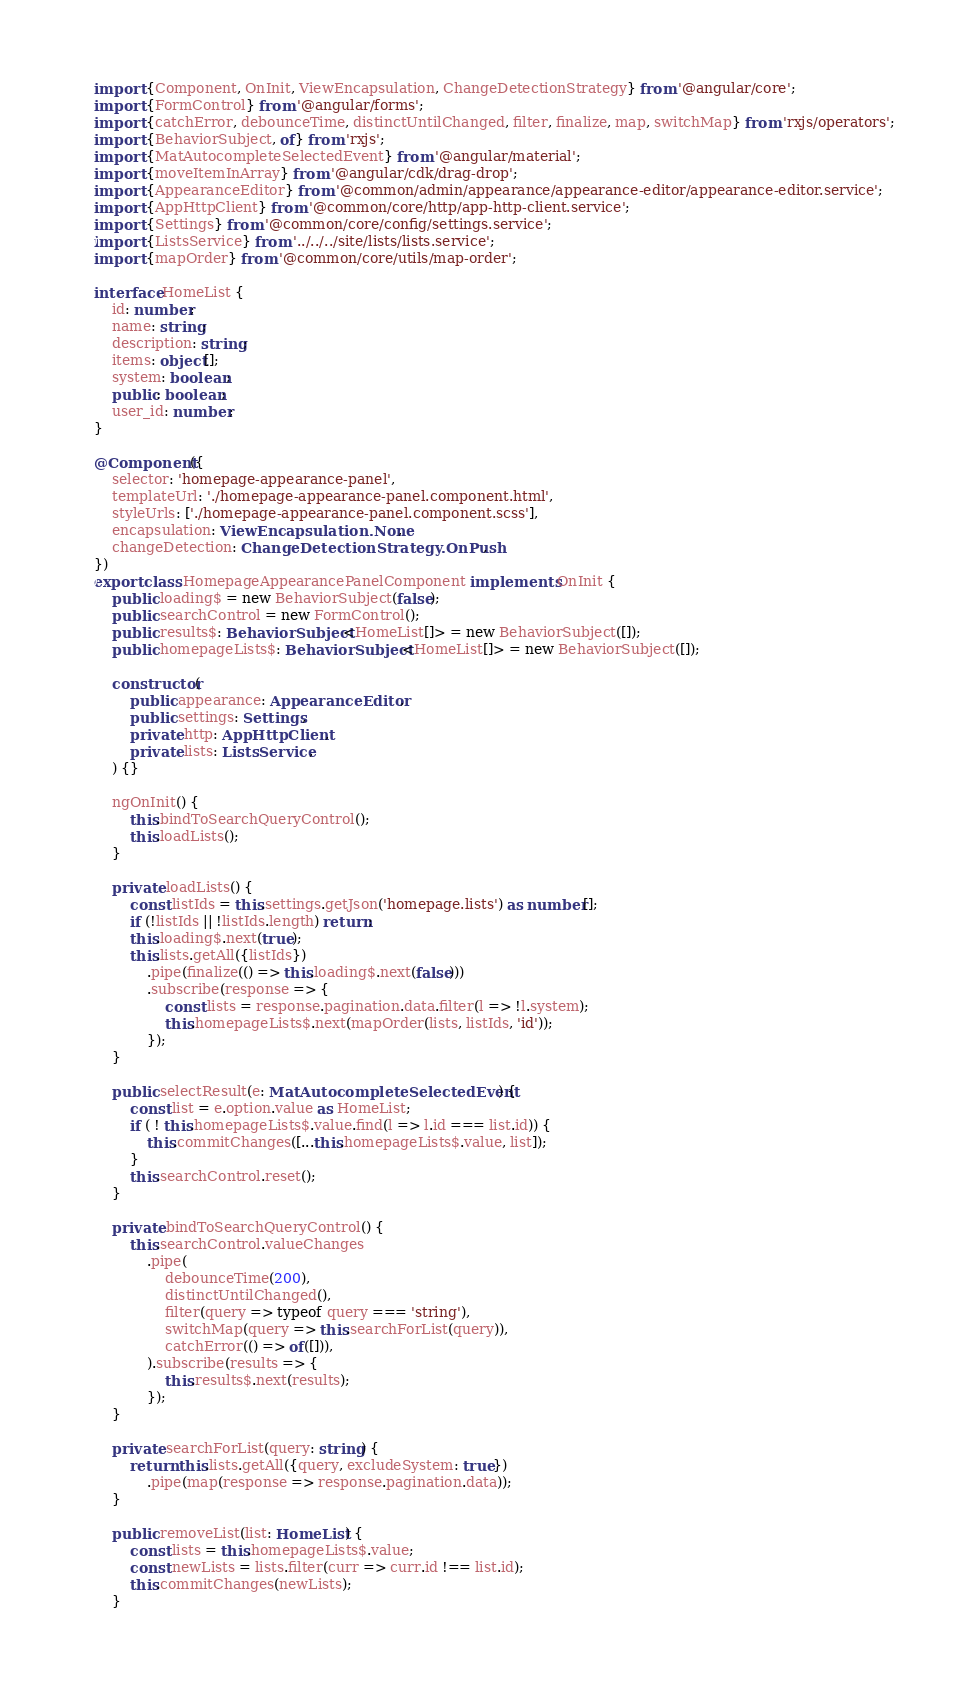<code> <loc_0><loc_0><loc_500><loc_500><_TypeScript_>import {Component, OnInit, ViewEncapsulation, ChangeDetectionStrategy} from '@angular/core';
import {FormControl} from '@angular/forms';
import {catchError, debounceTime, distinctUntilChanged, filter, finalize, map, switchMap} from 'rxjs/operators';
import {BehaviorSubject, of} from 'rxjs';
import {MatAutocompleteSelectedEvent} from '@angular/material';
import {moveItemInArray} from '@angular/cdk/drag-drop';
import {AppearanceEditor} from '@common/admin/appearance/appearance-editor/appearance-editor.service';
import {AppHttpClient} from '@common/core/http/app-http-client.service';
import {Settings} from '@common/core/config/settings.service';
import {ListsService} from '../../../site/lists/lists.service';
import {mapOrder} from '@common/core/utils/map-order';

interface HomeList {
    id: number;
    name: string;
    description: string;
    items: object[];
    system: boolean;
    public: boolean;
    user_id: number;
}

@Component({
    selector: 'homepage-appearance-panel',
    templateUrl: './homepage-appearance-panel.component.html',
    styleUrls: ['./homepage-appearance-panel.component.scss'],
    encapsulation: ViewEncapsulation.None,
    changeDetection: ChangeDetectionStrategy.OnPush,
})
export class HomepageAppearancePanelComponent implements OnInit {
    public loading$ = new BehaviorSubject(false);
    public searchControl = new FormControl();
    public results$: BehaviorSubject<HomeList[]> = new BehaviorSubject([]);
    public homepageLists$: BehaviorSubject<HomeList[]> = new BehaviorSubject([]);

    constructor(
        public appearance: AppearanceEditor,
        public settings: Settings,
        private http: AppHttpClient,
        private lists: ListsService,
    ) {}

    ngOnInit() {
        this.bindToSearchQueryControl();
        this.loadLists();
    }

    private loadLists() {
        const listIds = this.settings.getJson('homepage.lists') as number[];
        if (!listIds || !listIds.length) return;
        this.loading$.next(true);
        this.lists.getAll({listIds})
            .pipe(finalize(() => this.loading$.next(false)))
            .subscribe(response => {
                const lists = response.pagination.data.filter(l => !l.system);
                this.homepageLists$.next(mapOrder(lists, listIds, 'id'));
            });
    }

    public selectResult(e: MatAutocompleteSelectedEvent) {
        const list = e.option.value as HomeList;
        if ( ! this.homepageLists$.value.find(l => l.id === list.id)) {
            this.commitChanges([...this.homepageLists$.value, list]);
        }
        this.searchControl.reset();
    }

    private bindToSearchQueryControl() {
        this.searchControl.valueChanges
            .pipe(
                debounceTime(200),
                distinctUntilChanged(),
                filter(query => typeof query === 'string'),
                switchMap(query => this.searchForList(query)),
                catchError(() => of([])),
            ).subscribe(results => {
                this.results$.next(results);
            });
    }

    private searchForList(query: string) {
        return this.lists.getAll({query, excludeSystem: true})
            .pipe(map(response => response.pagination.data));
    }

    public removeList(list: HomeList) {
        const lists = this.homepageLists$.value;
        const newLists = lists.filter(curr => curr.id !== list.id);
        this.commitChanges(newLists);
    }
</code> 